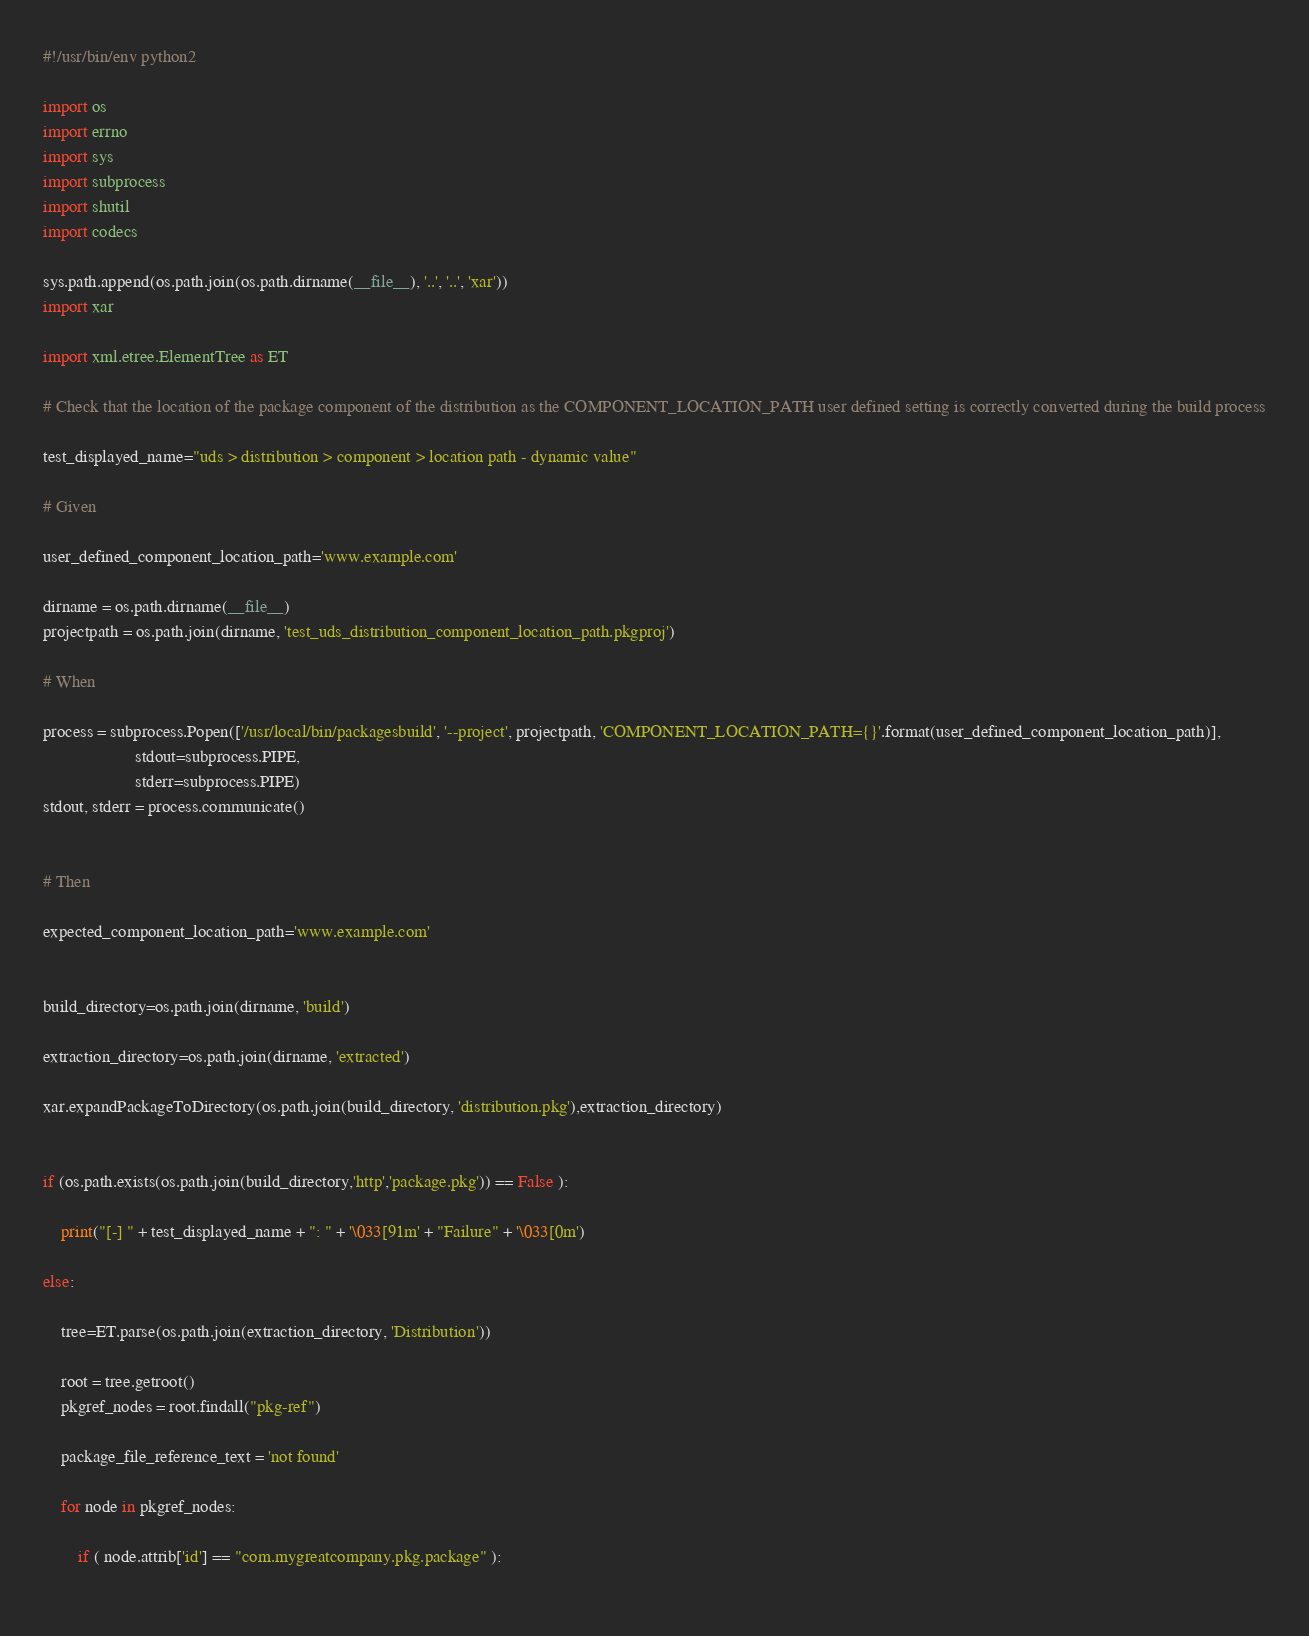<code> <loc_0><loc_0><loc_500><loc_500><_Python_>#!/usr/bin/env python2

import os
import errno
import sys
import subprocess
import shutil
import codecs

sys.path.append(os.path.join(os.path.dirname(__file__), '..', '..', 'xar'))
import xar

import xml.etree.ElementTree as ET

# Check that the location of the package component of the distribution as the COMPONENT_LOCATION_PATH user defined setting is correctly converted during the build process

test_displayed_name="uds > distribution > component > location path - dynamic value"

# Given

user_defined_component_location_path='www.example.com'

dirname = os.path.dirname(__file__)
projectpath = os.path.join(dirname, 'test_uds_distribution_component_location_path.pkgproj')

# When

process = subprocess.Popen(['/usr/local/bin/packagesbuild', '--project', projectpath, 'COMPONENT_LOCATION_PATH={}'.format(user_defined_component_location_path)],
                     stdout=subprocess.PIPE, 
                     stderr=subprocess.PIPE)
stdout, stderr = process.communicate()


# Then

expected_component_location_path='www.example.com'


build_directory=os.path.join(dirname, 'build')

extraction_directory=os.path.join(dirname, 'extracted')

xar.expandPackageToDirectory(os.path.join(build_directory, 'distribution.pkg'),extraction_directory)


if (os.path.exists(os.path.join(build_directory,'http','package.pkg')) == False ):

	print("[-] " + test_displayed_name + ": " + '\033[91m' + "Failure" + '\033[0m')

else:

	tree=ET.parse(os.path.join(extraction_directory, 'Distribution'))

	root = tree.getroot()
	pkgref_nodes = root.findall("pkg-ref")

	package_file_reference_text = 'not found'

	for node in pkgref_nodes:

		if ( node.attrib['id'] == "com.mygreatcompany.pkg.package" ):
	</code> 